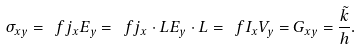<formula> <loc_0><loc_0><loc_500><loc_500>\sigma _ { x y } = \ f { j _ { x } } { E _ { y } } = \ f { j _ { x } \cdot L } { E _ { y } \cdot L } = \ f { I _ { x } } { V _ { y } } = G _ { x y } = \frac { \tilde { k } } { h } .</formula> 